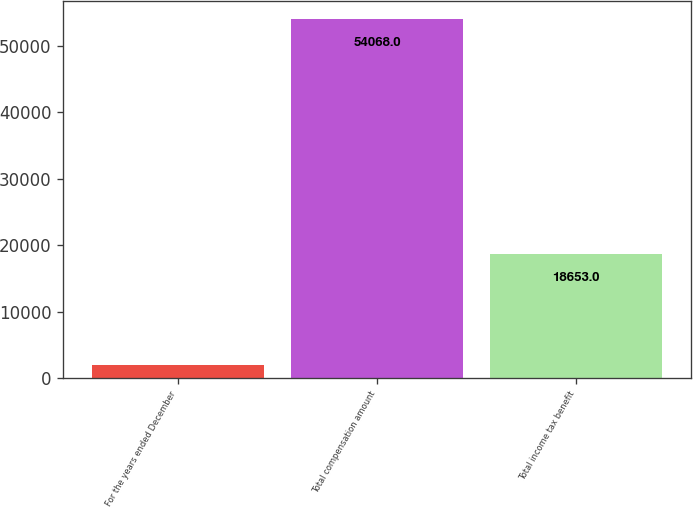Convert chart to OTSL. <chart><loc_0><loc_0><loc_500><loc_500><bar_chart><fcel>For the years ended December<fcel>Total compensation amount<fcel>Total income tax benefit<nl><fcel>2014<fcel>54068<fcel>18653<nl></chart> 